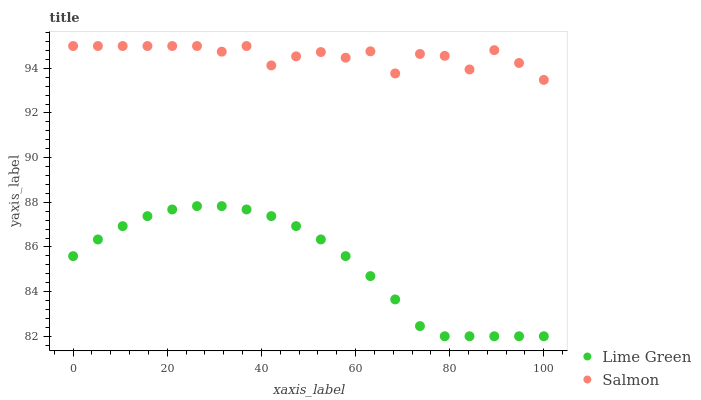Does Lime Green have the minimum area under the curve?
Answer yes or no. Yes. Does Salmon have the maximum area under the curve?
Answer yes or no. Yes. Does Lime Green have the maximum area under the curve?
Answer yes or no. No. Is Lime Green the smoothest?
Answer yes or no. Yes. Is Salmon the roughest?
Answer yes or no. Yes. Is Lime Green the roughest?
Answer yes or no. No. Does Lime Green have the lowest value?
Answer yes or no. Yes. Does Salmon have the highest value?
Answer yes or no. Yes. Does Lime Green have the highest value?
Answer yes or no. No. Is Lime Green less than Salmon?
Answer yes or no. Yes. Is Salmon greater than Lime Green?
Answer yes or no. Yes. Does Lime Green intersect Salmon?
Answer yes or no. No. 